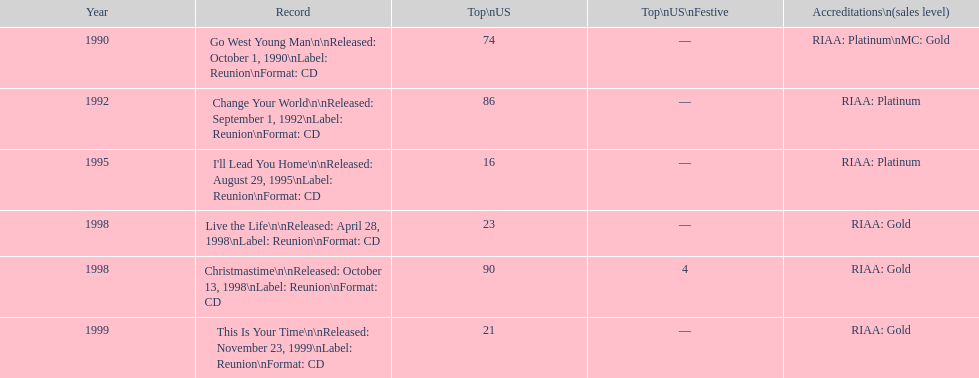What was the debut michael w. smith album? Go West Young Man. 